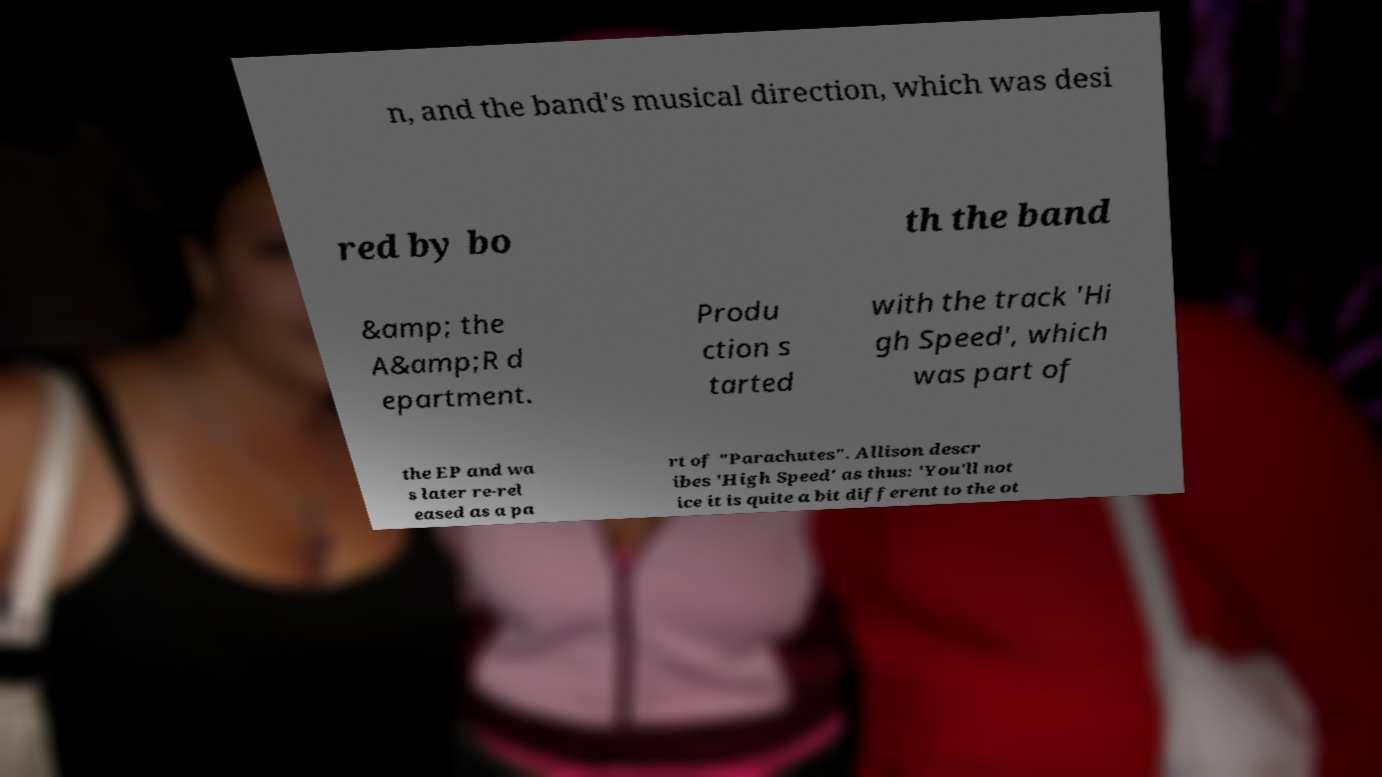I need the written content from this picture converted into text. Can you do that? n, and the band's musical direction, which was desi red by bo th the band &amp; the A&amp;R d epartment. Produ ction s tarted with the track 'Hi gh Speed', which was part of the EP and wa s later re-rel eased as a pa rt of "Parachutes". Allison descr ibes 'High Speed' as thus: 'You'll not ice it is quite a bit different to the ot 